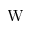<formula> <loc_0><loc_0><loc_500><loc_500>W</formula> 